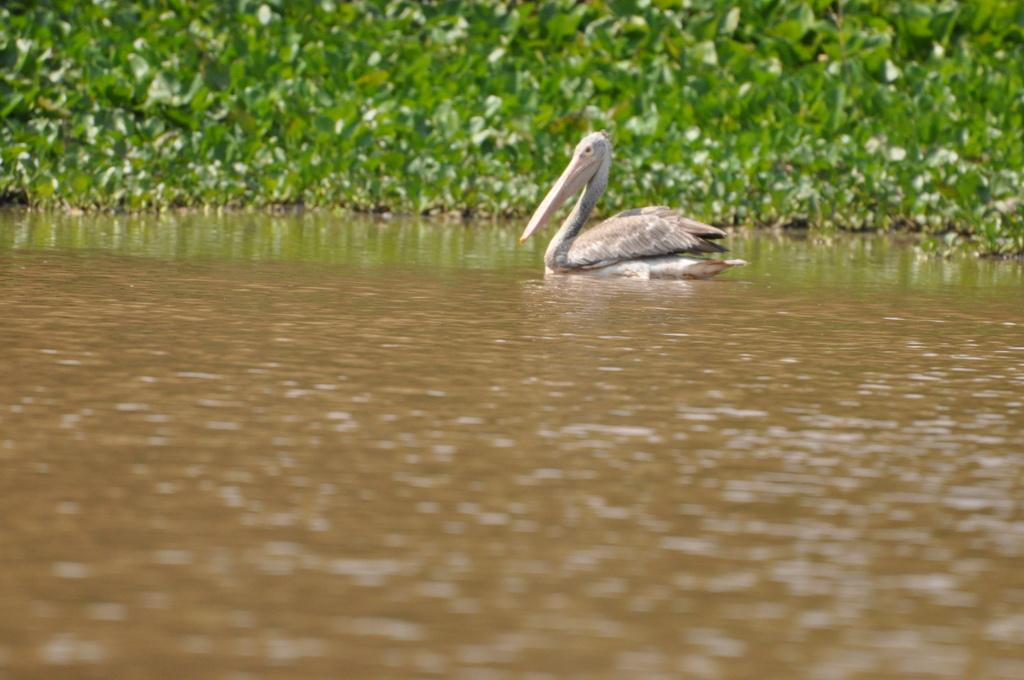What type of animal is in the image? There is a water bird in the image. What is the water bird doing in the image? The water bird is sitting on the water. What can be seen in the background of the image? There are plants in the background of the image. What color are the plants in the image? The plants are green in color. How does the water bird act as a guide for the salt in the image? There is no salt present in the image, and the water bird is not acting as a guide for any salt. 